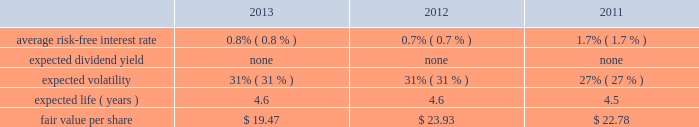Edwards lifesciences corporation notes to consolidated financial statements ( continued ) 12 .
Common stock ( continued ) the company also maintains the nonemployee directors stock incentive compensation program ( the 2018 2018nonemployee directors program 2019 2019 ) .
Under the nonemployee directors program , each nonemployee director may receive annually up to 10000 stock options or 4000 restricted stock units of the company 2019s common stock , or a combination thereof , provided that in no event may the total value of the combined annual award exceed $ 0.2 million .
Additionally , each nonemployee director may elect to receive all or a portion of the annual cash retainer to which the director is otherwise entitled through the issuance of stock options or restricted stock units .
Each option and restricted stock unit award granted in 2011 or prior generally vests in three equal annual installments .
Each option and restricted stock unit award granted after 2011 generally vests after one year .
Upon a director 2019s initial election to the board , the director receives an initial grant of restricted stock units equal to a fair market value on grant date of $ 0.2 million , not to exceed 10000 shares .
These grants vest over three years from the date of grant .
Under the nonemployee directors program , an aggregate of 1.4 million shares of the company 2019s common stock has been authorized for issuance .
The company has an employee stock purchase plan for united states employees and a plan for international employees ( collectively 2018 2018espp 2019 2019 ) .
Under the espp , eligible employees may purchase shares of the company 2019s common stock at 85% ( 85 % ) of the lower of the fair market value of edwards lifesciences common stock on the effective date of subscription or the date of purchase .
Under the espp , employees can authorize the company to withhold up to 12% ( 12 % ) of their compensation for common stock purchases , subject to certain limitations .
The espp is available to all active employees of the company paid from the united states payroll and to eligible employees of the company outside the united states to the extent permitted by local law .
The espp for united states employees is qualified under section 423 of the internal revenue code .
The number of shares of common stock authorized for issuance under the espp was 6.6 million shares .
The fair value of each option award and employee stock purchase subscription is estimated on the date of grant using the black-scholes option valuation model that uses the assumptions noted in the tables .
The risk-free interest rate is estimated using the u.s .
Treasury yield curve and is based on the expected term of the award .
Expected volatility is estimated based on a blend of the weighted-average of the historical volatility of edwards 2019 stock and the implied volatility from traded options on edwards 2019 stock .
The expected term of awards granted is estimated from the vesting period of the award , as well as historical exercise behavior , and represents the period of time that awards granted are expected to be outstanding .
The company uses historical data to estimate forfeitures and has estimated an annual forfeiture rate of 5.1% ( 5.1 % ) .
The black-scholes option pricing model was used with the following weighted-average assumptions for options granted during the following periods : option awards .

What is the percentage change in the fair value per share between 2012 and 2013? 
Computations: ((19.47 - 23.93) / 23.93)
Answer: -0.18638. 